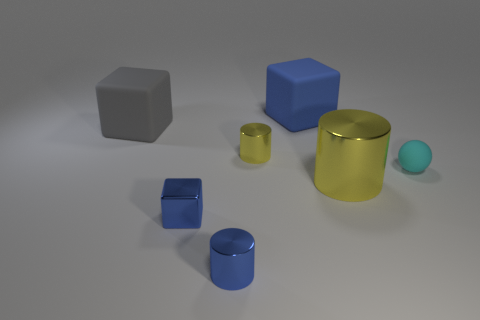Add 3 tiny cyan matte spheres. How many objects exist? 10 Subtract all cylinders. How many objects are left? 4 Add 4 yellow metallic objects. How many yellow metallic objects exist? 6 Subtract 0 green blocks. How many objects are left? 7 Subtract all blue shiny objects. Subtract all gray objects. How many objects are left? 4 Add 6 large gray cubes. How many large gray cubes are left? 7 